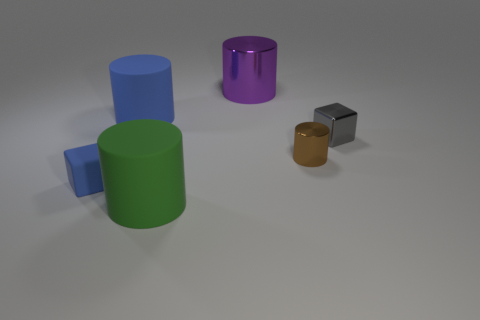Are the large cylinder that is in front of the tiny blue matte cube and the tiny thing on the left side of the purple shiny thing made of the same material?
Give a very brief answer. Yes. Is there anything else that has the same shape as the large blue thing?
Your answer should be very brief. Yes. Is the small gray cube made of the same material as the tiny thing that is to the left of the green cylinder?
Give a very brief answer. No. The rubber cylinder that is behind the cube that is to the right of the small cube left of the gray object is what color?
Provide a succinct answer. Blue. What shape is the blue rubber thing that is the same size as the brown thing?
Your answer should be compact. Cube. Is there anything else that is the same size as the purple cylinder?
Make the answer very short. Yes. There is a cube in front of the brown shiny thing; is it the same size as the blue matte thing to the right of the tiny blue rubber cube?
Your answer should be compact. No. How big is the cube right of the large green cylinder?
Keep it short and to the point. Small. What material is the big cylinder that is the same color as the tiny rubber block?
Your answer should be very brief. Rubber. The metallic object that is the same size as the green rubber thing is what color?
Provide a short and direct response. Purple. 